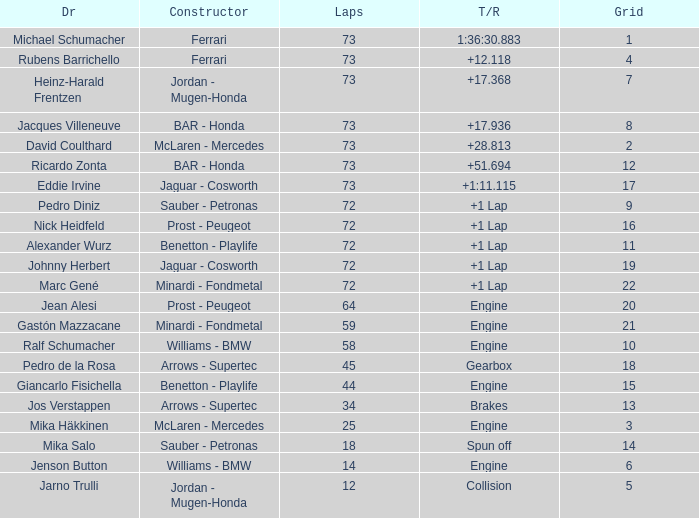How many laps did Jos Verstappen do on Grid 2? 34.0. 